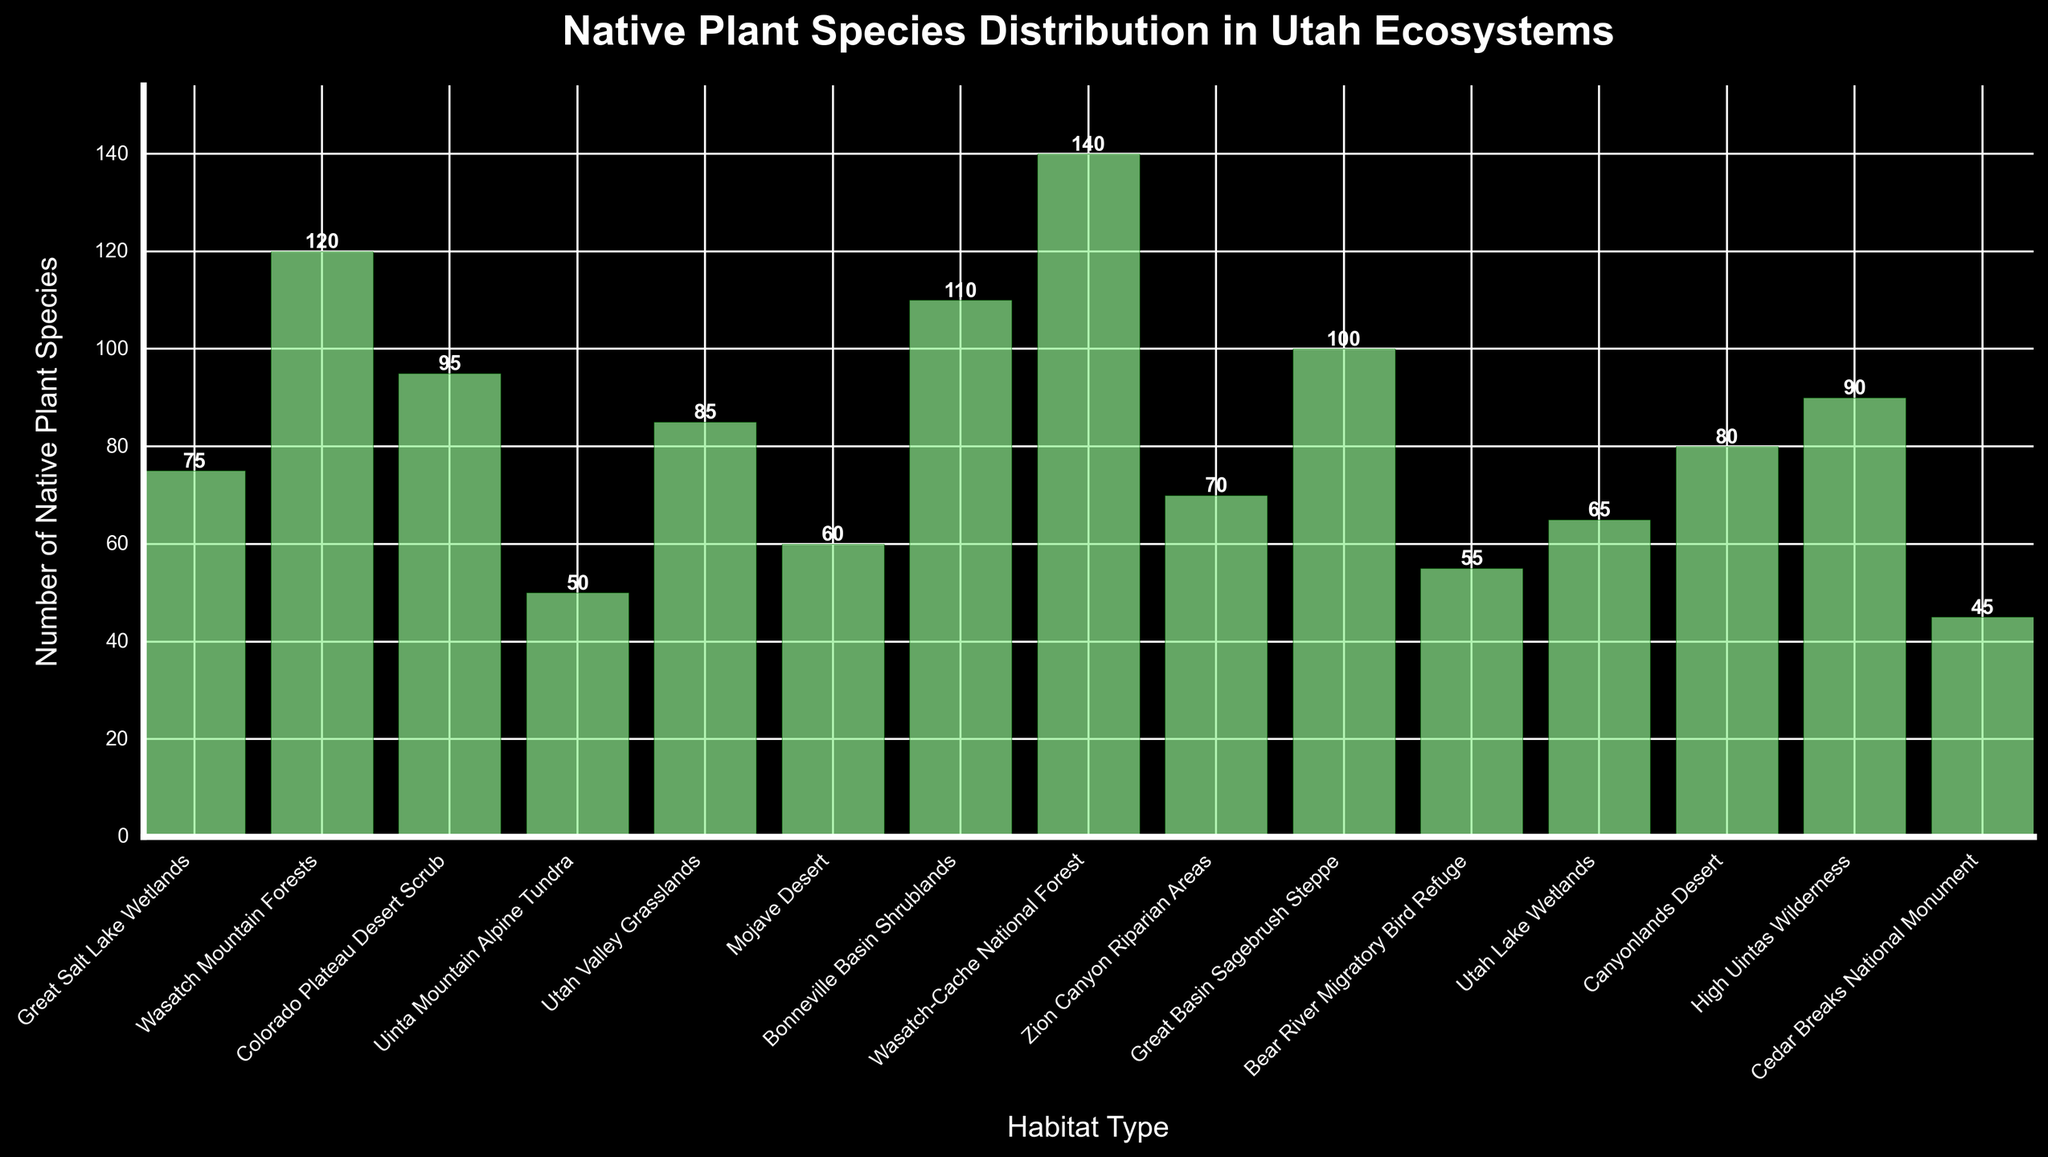Which habitat type has the highest number of native plant species? The Wasatch-Cache National Forest has the tallest bar, representing the highest number of native plant species.
Answer: Wasatch-Cache National Forest What is the total number of native plant species in the Utah Valley Grasslands and Canyonlands Desert combined? Utah Valley Grasslands has 85 species and Canyonlands Desert has 80 species. Summing them up gives 85 + 80 = 165.
Answer: 165 Which habitat type has more native plant species, Great Basin Sagebrush Steppe or Cedar Breaks National Monument? The bar for Great Basin Sagebrush Steppe is taller than that for Cedar Breaks National Monument, indicating more native plant species.
Answer: Great Basin Sagebrush Steppe How many more native plant species does the Wasatch-Cache National Forest have compared to the Great Salt Lake Wetlands? Wasatch-Cache National Forest has 140 species, Great Salt Lake Wetlands has 75 species. The difference is 140 - 75 = 65.
Answer: 65 What is the average number of native plant species across Mojave Desert, Bear River Migratory Bird Refuge, and Utah Lake Wetlands? Mojave Desert has 60, Bear River Migratory Bird Refuge has 55, and Utah Lake Wetlands has 65 species. The average is (60 + 55 + 65) / 3 = 60.
Answer: 60 Which bar represents the Uinta Mountain Alpine Tundra and the Utah Lake Wetlands, and how do their heights compare? The Uinta Mountain Alpine Tundra bar has 50 species while the Utah Lake Wetlands bar has 65 species; the Utah Lake Wetlands bar is taller.
Answer: Utah Lake Wetlands is taller What is the sum of native plant species in the habitats within Great Basin (Bonneville Basin Shrublands, Great Basin Sagebrush Steppe)? Bonneville Basin Shrublands has 110 species and Great Basin Sagebrush Steppe has 100 species, summing up to 110 + 100 = 210.
Answer: 210 Among the listed habitats, which one has the least number of native plant species, and how many species are present? Cedar Breaks National Monument has the shortest bar, indicating the least number of native plant species with 45.
Answer: Cedar Breaks National Monument, 45 How does the number of species in Zion Canyon Riparian Areas compare to that in the Wasatch Mountain Forests? Zion Canyon Riparian Areas has 70 species, whereas Wasatch Mountain Forests has 120 species; Zion Canyon Riparian Areas has fewer species.
Answer: Zion Canyon Riparian Areas has fewer species What’s the difference in the number of native plant species between the Bear River Migratory Bird Refuge and the High Uintas Wilderness? Bear River Migratory Bird Refuge has 55 species and High Uintas Wilderness has 90 species, the difference is 90 - 55 = 35.
Answer: 35 